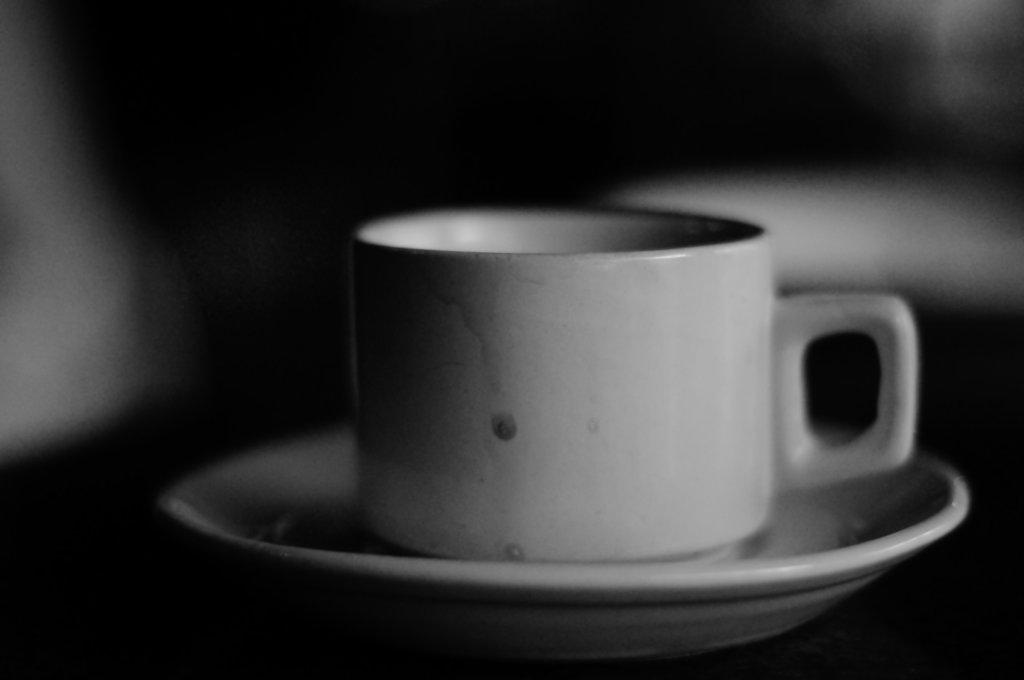What is the color scheme of the image? The image is black and white. What objects can be seen on the table in the image? There is a cup on a saucer in the image. How much attention is the corn receiving in the image? There is no corn present in the image, so it cannot receive any attention. 